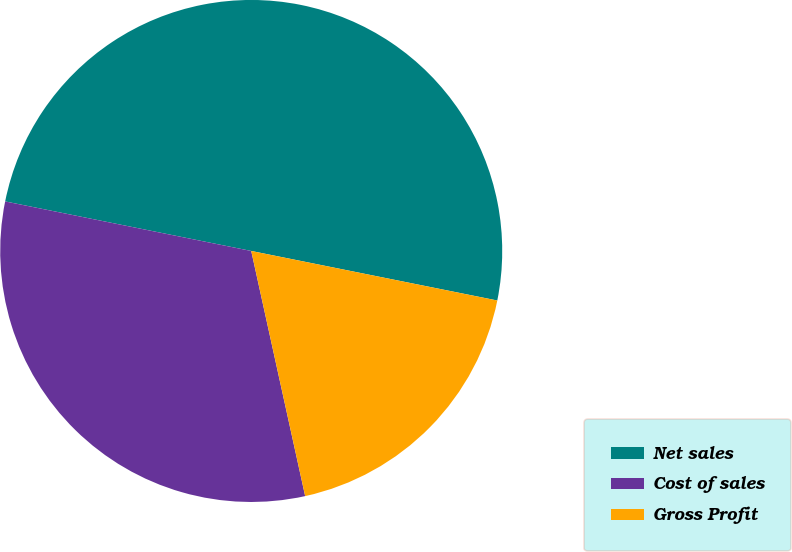Convert chart. <chart><loc_0><loc_0><loc_500><loc_500><pie_chart><fcel>Net sales<fcel>Cost of sales<fcel>Gross Profit<nl><fcel>50.0%<fcel>31.61%<fcel>18.39%<nl></chart> 